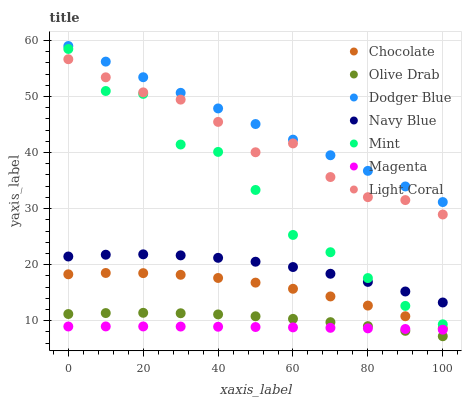Does Magenta have the minimum area under the curve?
Answer yes or no. Yes. Does Dodger Blue have the maximum area under the curve?
Answer yes or no. Yes. Does Chocolate have the minimum area under the curve?
Answer yes or no. No. Does Chocolate have the maximum area under the curve?
Answer yes or no. No. Is Dodger Blue the smoothest?
Answer yes or no. Yes. Is Mint the roughest?
Answer yes or no. Yes. Is Chocolate the smoothest?
Answer yes or no. No. Is Chocolate the roughest?
Answer yes or no. No. Does Olive Drab have the lowest value?
Answer yes or no. Yes. Does Chocolate have the lowest value?
Answer yes or no. No. Does Dodger Blue have the highest value?
Answer yes or no. Yes. Does Chocolate have the highest value?
Answer yes or no. No. Is Magenta less than Light Coral?
Answer yes or no. Yes. Is Dodger Blue greater than Olive Drab?
Answer yes or no. Yes. Does Magenta intersect Olive Drab?
Answer yes or no. Yes. Is Magenta less than Olive Drab?
Answer yes or no. No. Is Magenta greater than Olive Drab?
Answer yes or no. No. Does Magenta intersect Light Coral?
Answer yes or no. No. 